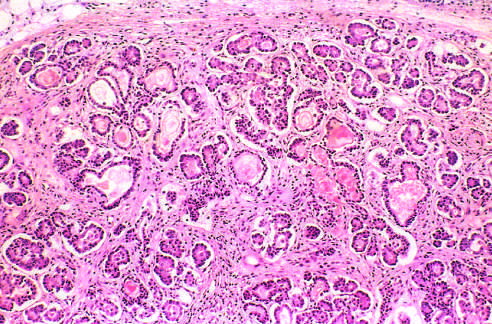what are dilated and plugged with eosinophilic mucin?
Answer the question using a single word or phrase. The ducts 